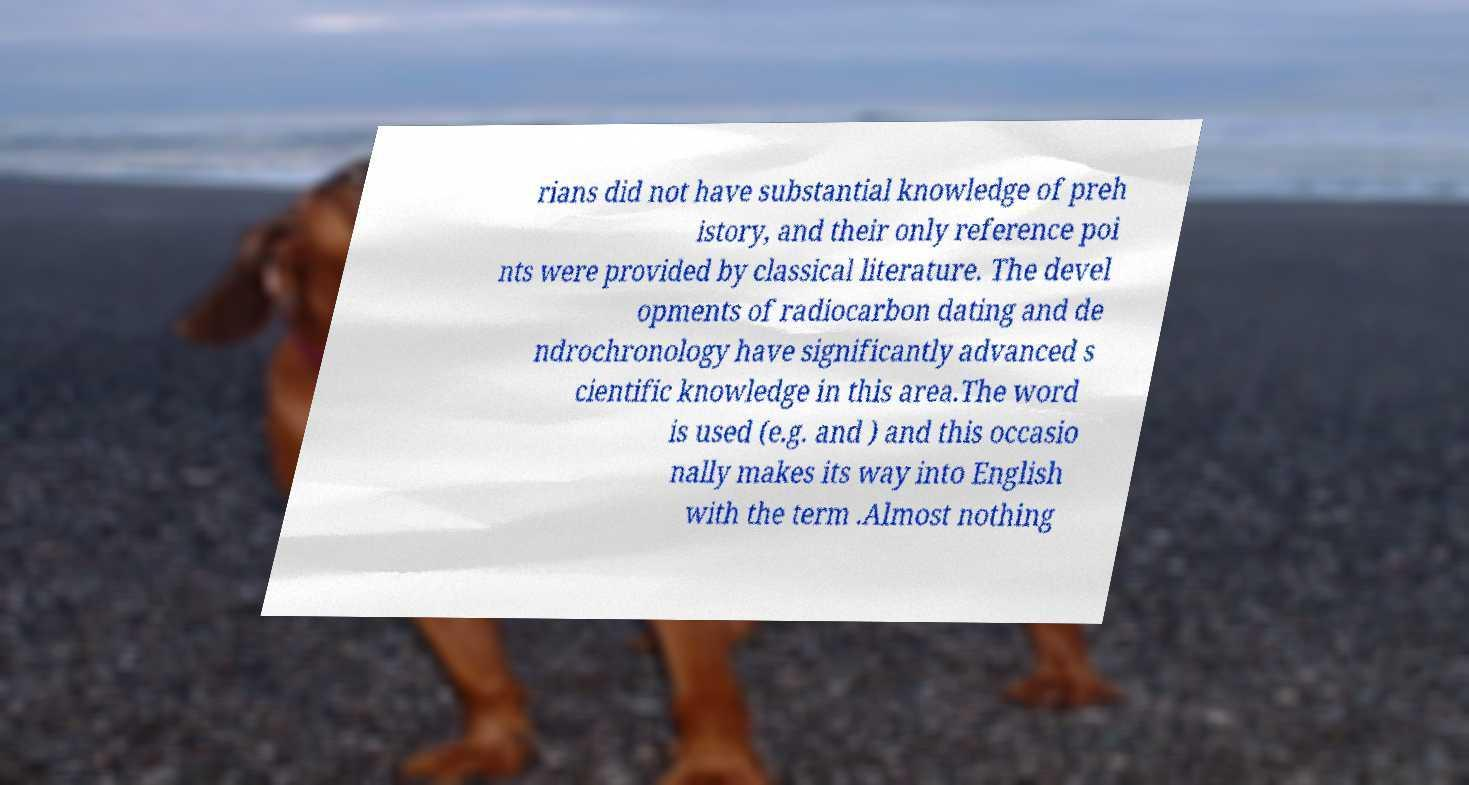Can you read and provide the text displayed in the image?This photo seems to have some interesting text. Can you extract and type it out for me? rians did not have substantial knowledge of preh istory, and their only reference poi nts were provided by classical literature. The devel opments of radiocarbon dating and de ndrochronology have significantly advanced s cientific knowledge in this area.The word is used (e.g. and ) and this occasio nally makes its way into English with the term .Almost nothing 